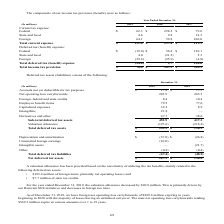According to Sealed Air Corporation's financial document, Of deferred tax assets, how much state tax credits were there? According to the financial document, $7.7 million. The relevant text states: "reign items, primarily net operating losses; and • $7.7 million of state tax credits...." Also, What does the table show? According to the financial document, Deferred tax assets. The relevant text states: "Deferred tax assets (liabilities) consist of the following:..." Also, How much did the valuation allowance decrease by in 2019? According to the financial document, $20.8 million. The relevant text states: "ber 31, 2019, the valuation allowance decreased by $20.8 million. This is primarily driven by our Reinvent SEE initiatives and decreases in foreign tax rates...." Also, can you calculate: What is the percentage change of Net deferred tax assets from 2018 to 2019? To answer this question, I need to perform calculations using the financial data. The calculation is: (207.9-150.0)/150.0, which equals 38.6 (percentage). This is based on the information: "Net deferred tax assets $ 207.9 $ 150.0 Net deferred tax assets $ 207.9 $ 150.0..." The key data points involved are: 150.0, 207.9. Also, can you calculate: What is the percentage of deferred tax assets in foreign items to valuation allowance in 2019? Based on the calculation: 183.4/197.6, the result is 92.81 (percentage). This is based on the information: "Valuation allowance (197.6) (218.4) Total deferred tax assets $ 255.3 $ 198.9 related to the following deferred tax assets: • $183.4 million of foreign items, primarily net operating losses; and • $7...." The key data points involved are: 183.4, 197.6. Also, can you calculate: What is the value of Sub-total deferred tax assets as a percentage of Net deferred tax assets for 2019? Based on the calculation: 452.9/207.9, the result is 217.85 (percentage). This is based on the information: "Net deferred tax assets $ 207.9 $ 150.0 Sub-total deferred tax assets 452.9 417.3..." The key data points involved are: 207.9, 452.9. 